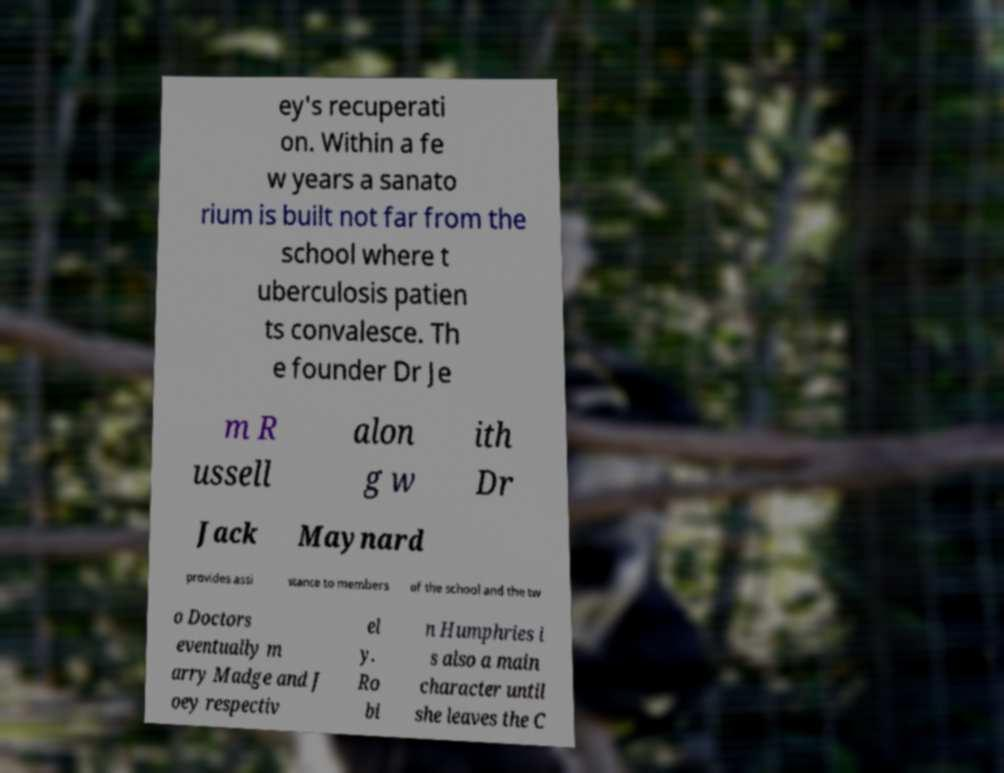For documentation purposes, I need the text within this image transcribed. Could you provide that? ey's recuperati on. Within a fe w years a sanato rium is built not far from the school where t uberculosis patien ts convalesce. Th e founder Dr Je m R ussell alon g w ith Dr Jack Maynard provides assi stance to members of the school and the tw o Doctors eventually m arry Madge and J oey respectiv el y. Ro bi n Humphries i s also a main character until she leaves the C 